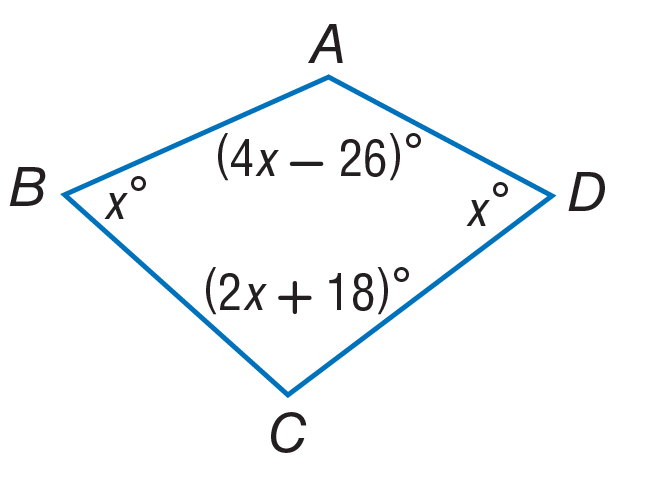Answer the mathemtical geometry problem and directly provide the correct option letter.
Question: Find the measure of \angle D.
Choices: A: 46 B: 92 C: 110 D: 143 A 